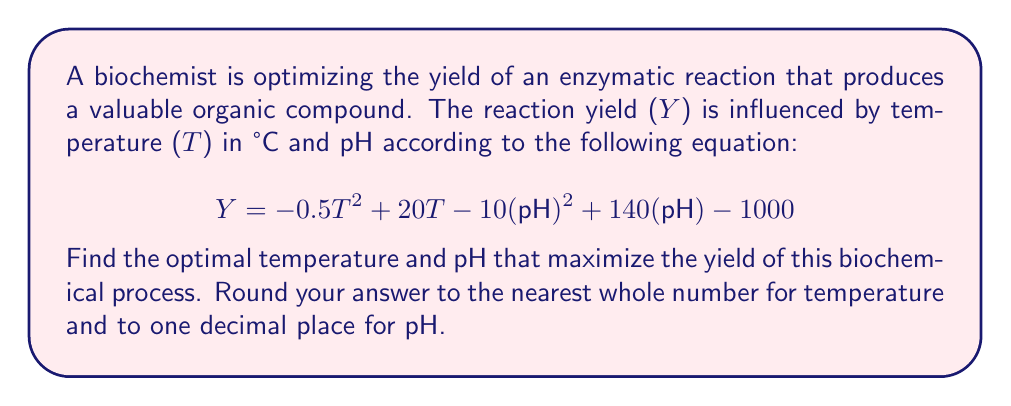Can you solve this math problem? To find the maximum yield, we need to find the values of T and pH that maximize the function Y. This is a two-variable optimization problem that can be solved using partial derivatives.

1. Take the partial derivative of Y with respect to T:
   $$\frac{\partial Y}{\partial T} = -T + 20$$

2. Take the partial derivative of Y with respect to pH:
   $$\frac{\partial Y}{\partial pH} = -20(pH) + 140$$

3. Set both partial derivatives equal to zero and solve:

   For T: $-T + 20 = 0$
          $T = 20$

   For pH: $-20(pH) + 140 = 0$
           $-20(pH) = -140$
           $pH = 7$

4. To confirm this is a maximum (not a minimum), we can check the second partial derivatives:

   $$\frac{\partial^2 Y}{\partial T^2} = -1 < 0$$
   $$\frac{\partial^2 Y}{\partial (pH)^2} = -20 < 0$$

   Both second derivatives are negative, confirming a maximum.

5. Calculate the yield at these optimal conditions:
   $$Y = -0.5(20)^2 + 20(20) - 10(7)^2 + 140(7) - 1000$$
   $$= -200 + 400 - 490 + 980 - 1000$$
   $$= -310$$

Therefore, the optimal conditions are:
Temperature = 20°C
pH = 7.0

These conditions result in a maximum yield of -310 (note that this negative value might represent a relative yield or could indicate an error in the original equation).
Answer: Optimal temperature: 20°C
Optimal pH: 7.0 